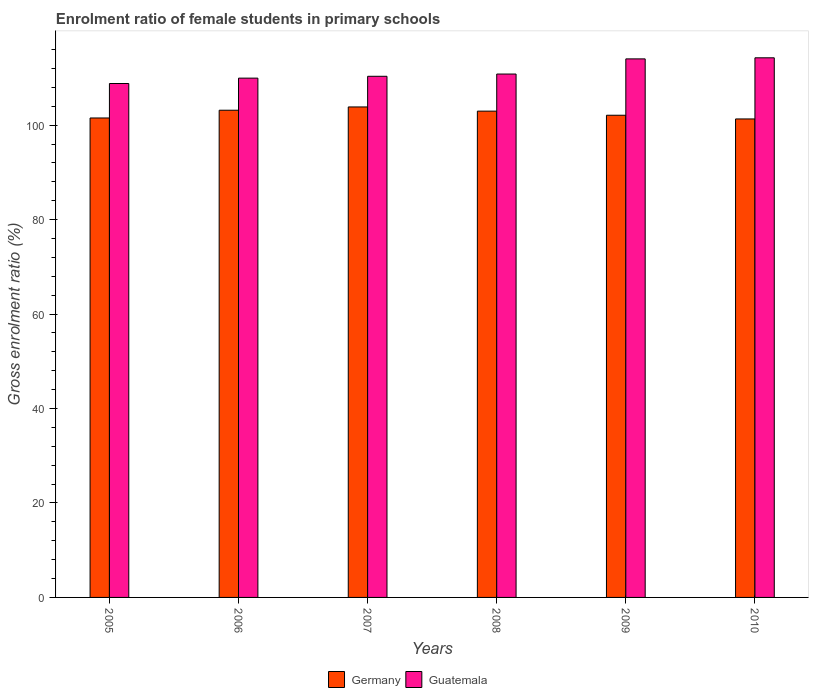What is the label of the 4th group of bars from the left?
Provide a short and direct response. 2008. In how many cases, is the number of bars for a given year not equal to the number of legend labels?
Your answer should be compact. 0. What is the enrolment ratio of female students in primary schools in Guatemala in 2007?
Provide a short and direct response. 110.36. Across all years, what is the maximum enrolment ratio of female students in primary schools in Guatemala?
Offer a very short reply. 114.27. Across all years, what is the minimum enrolment ratio of female students in primary schools in Guatemala?
Your response must be concise. 108.83. In which year was the enrolment ratio of female students in primary schools in Germany maximum?
Offer a terse response. 2007. What is the total enrolment ratio of female students in primary schools in Germany in the graph?
Your answer should be compact. 614.99. What is the difference between the enrolment ratio of female students in primary schools in Germany in 2009 and that in 2010?
Your response must be concise. 0.78. What is the difference between the enrolment ratio of female students in primary schools in Germany in 2007 and the enrolment ratio of female students in primary schools in Guatemala in 2005?
Your response must be concise. -4.97. What is the average enrolment ratio of female students in primary schools in Germany per year?
Offer a terse response. 102.5. In the year 2006, what is the difference between the enrolment ratio of female students in primary schools in Guatemala and enrolment ratio of female students in primary schools in Germany?
Make the answer very short. 6.8. In how many years, is the enrolment ratio of female students in primary schools in Germany greater than 32 %?
Your response must be concise. 6. What is the ratio of the enrolment ratio of female students in primary schools in Guatemala in 2005 to that in 2006?
Your response must be concise. 0.99. Is the enrolment ratio of female students in primary schools in Guatemala in 2006 less than that in 2010?
Make the answer very short. Yes. What is the difference between the highest and the second highest enrolment ratio of female students in primary schools in Germany?
Provide a short and direct response. 0.69. What is the difference between the highest and the lowest enrolment ratio of female students in primary schools in Germany?
Offer a very short reply. 2.54. In how many years, is the enrolment ratio of female students in primary schools in Guatemala greater than the average enrolment ratio of female students in primary schools in Guatemala taken over all years?
Make the answer very short. 2. What does the 1st bar from the right in 2006 represents?
Provide a short and direct response. Guatemala. How many years are there in the graph?
Give a very brief answer. 6. What is the difference between two consecutive major ticks on the Y-axis?
Give a very brief answer. 20. Are the values on the major ticks of Y-axis written in scientific E-notation?
Provide a short and direct response. No. Does the graph contain grids?
Offer a terse response. No. Where does the legend appear in the graph?
Provide a short and direct response. Bottom center. How many legend labels are there?
Your response must be concise. 2. What is the title of the graph?
Offer a terse response. Enrolment ratio of female students in primary schools. Does "Curacao" appear as one of the legend labels in the graph?
Provide a succinct answer. No. What is the Gross enrolment ratio (%) in Germany in 2005?
Make the answer very short. 101.53. What is the Gross enrolment ratio (%) of Guatemala in 2005?
Make the answer very short. 108.83. What is the Gross enrolment ratio (%) of Germany in 2006?
Offer a very short reply. 103.17. What is the Gross enrolment ratio (%) of Guatemala in 2006?
Ensure brevity in your answer.  109.97. What is the Gross enrolment ratio (%) of Germany in 2007?
Keep it short and to the point. 103.87. What is the Gross enrolment ratio (%) in Guatemala in 2007?
Offer a terse response. 110.36. What is the Gross enrolment ratio (%) in Germany in 2008?
Your response must be concise. 102.98. What is the Gross enrolment ratio (%) of Guatemala in 2008?
Keep it short and to the point. 110.84. What is the Gross enrolment ratio (%) of Germany in 2009?
Provide a short and direct response. 102.11. What is the Gross enrolment ratio (%) of Guatemala in 2009?
Give a very brief answer. 114.05. What is the Gross enrolment ratio (%) of Germany in 2010?
Provide a succinct answer. 101.33. What is the Gross enrolment ratio (%) of Guatemala in 2010?
Ensure brevity in your answer.  114.27. Across all years, what is the maximum Gross enrolment ratio (%) in Germany?
Make the answer very short. 103.87. Across all years, what is the maximum Gross enrolment ratio (%) in Guatemala?
Offer a very short reply. 114.27. Across all years, what is the minimum Gross enrolment ratio (%) of Germany?
Make the answer very short. 101.33. Across all years, what is the minimum Gross enrolment ratio (%) in Guatemala?
Offer a terse response. 108.83. What is the total Gross enrolment ratio (%) in Germany in the graph?
Keep it short and to the point. 614.99. What is the total Gross enrolment ratio (%) in Guatemala in the graph?
Your answer should be compact. 668.32. What is the difference between the Gross enrolment ratio (%) of Germany in 2005 and that in 2006?
Your answer should be compact. -1.64. What is the difference between the Gross enrolment ratio (%) of Guatemala in 2005 and that in 2006?
Your response must be concise. -1.14. What is the difference between the Gross enrolment ratio (%) in Germany in 2005 and that in 2007?
Your answer should be very brief. -2.34. What is the difference between the Gross enrolment ratio (%) in Guatemala in 2005 and that in 2007?
Your response must be concise. -1.53. What is the difference between the Gross enrolment ratio (%) in Germany in 2005 and that in 2008?
Keep it short and to the point. -1.45. What is the difference between the Gross enrolment ratio (%) in Guatemala in 2005 and that in 2008?
Your answer should be very brief. -2. What is the difference between the Gross enrolment ratio (%) in Germany in 2005 and that in 2009?
Give a very brief answer. -0.58. What is the difference between the Gross enrolment ratio (%) in Guatemala in 2005 and that in 2009?
Your answer should be compact. -5.21. What is the difference between the Gross enrolment ratio (%) in Germany in 2005 and that in 2010?
Your answer should be compact. 0.2. What is the difference between the Gross enrolment ratio (%) in Guatemala in 2005 and that in 2010?
Your answer should be compact. -5.44. What is the difference between the Gross enrolment ratio (%) in Germany in 2006 and that in 2007?
Ensure brevity in your answer.  -0.69. What is the difference between the Gross enrolment ratio (%) in Guatemala in 2006 and that in 2007?
Your answer should be very brief. -0.39. What is the difference between the Gross enrolment ratio (%) in Germany in 2006 and that in 2008?
Give a very brief answer. 0.19. What is the difference between the Gross enrolment ratio (%) of Guatemala in 2006 and that in 2008?
Keep it short and to the point. -0.87. What is the difference between the Gross enrolment ratio (%) in Germany in 2006 and that in 2009?
Provide a succinct answer. 1.06. What is the difference between the Gross enrolment ratio (%) in Guatemala in 2006 and that in 2009?
Your response must be concise. -4.08. What is the difference between the Gross enrolment ratio (%) of Germany in 2006 and that in 2010?
Your response must be concise. 1.85. What is the difference between the Gross enrolment ratio (%) of Guatemala in 2006 and that in 2010?
Keep it short and to the point. -4.31. What is the difference between the Gross enrolment ratio (%) in Germany in 2007 and that in 2008?
Provide a short and direct response. 0.89. What is the difference between the Gross enrolment ratio (%) in Guatemala in 2007 and that in 2008?
Provide a succinct answer. -0.48. What is the difference between the Gross enrolment ratio (%) in Germany in 2007 and that in 2009?
Provide a succinct answer. 1.76. What is the difference between the Gross enrolment ratio (%) in Guatemala in 2007 and that in 2009?
Ensure brevity in your answer.  -3.69. What is the difference between the Gross enrolment ratio (%) of Germany in 2007 and that in 2010?
Your answer should be compact. 2.54. What is the difference between the Gross enrolment ratio (%) in Guatemala in 2007 and that in 2010?
Keep it short and to the point. -3.91. What is the difference between the Gross enrolment ratio (%) in Germany in 2008 and that in 2009?
Offer a terse response. 0.87. What is the difference between the Gross enrolment ratio (%) in Guatemala in 2008 and that in 2009?
Offer a very short reply. -3.21. What is the difference between the Gross enrolment ratio (%) of Germany in 2008 and that in 2010?
Offer a very short reply. 1.65. What is the difference between the Gross enrolment ratio (%) of Guatemala in 2008 and that in 2010?
Keep it short and to the point. -3.44. What is the difference between the Gross enrolment ratio (%) in Germany in 2009 and that in 2010?
Provide a short and direct response. 0.78. What is the difference between the Gross enrolment ratio (%) in Guatemala in 2009 and that in 2010?
Provide a succinct answer. -0.23. What is the difference between the Gross enrolment ratio (%) in Germany in 2005 and the Gross enrolment ratio (%) in Guatemala in 2006?
Keep it short and to the point. -8.44. What is the difference between the Gross enrolment ratio (%) in Germany in 2005 and the Gross enrolment ratio (%) in Guatemala in 2007?
Give a very brief answer. -8.83. What is the difference between the Gross enrolment ratio (%) in Germany in 2005 and the Gross enrolment ratio (%) in Guatemala in 2008?
Provide a succinct answer. -9.3. What is the difference between the Gross enrolment ratio (%) in Germany in 2005 and the Gross enrolment ratio (%) in Guatemala in 2009?
Ensure brevity in your answer.  -12.51. What is the difference between the Gross enrolment ratio (%) in Germany in 2005 and the Gross enrolment ratio (%) in Guatemala in 2010?
Make the answer very short. -12.74. What is the difference between the Gross enrolment ratio (%) of Germany in 2006 and the Gross enrolment ratio (%) of Guatemala in 2007?
Offer a terse response. -7.19. What is the difference between the Gross enrolment ratio (%) of Germany in 2006 and the Gross enrolment ratio (%) of Guatemala in 2008?
Your answer should be compact. -7.66. What is the difference between the Gross enrolment ratio (%) in Germany in 2006 and the Gross enrolment ratio (%) in Guatemala in 2009?
Ensure brevity in your answer.  -10.87. What is the difference between the Gross enrolment ratio (%) in Germany in 2006 and the Gross enrolment ratio (%) in Guatemala in 2010?
Give a very brief answer. -11.1. What is the difference between the Gross enrolment ratio (%) in Germany in 2007 and the Gross enrolment ratio (%) in Guatemala in 2008?
Ensure brevity in your answer.  -6.97. What is the difference between the Gross enrolment ratio (%) in Germany in 2007 and the Gross enrolment ratio (%) in Guatemala in 2009?
Offer a terse response. -10.18. What is the difference between the Gross enrolment ratio (%) in Germany in 2007 and the Gross enrolment ratio (%) in Guatemala in 2010?
Your answer should be compact. -10.41. What is the difference between the Gross enrolment ratio (%) of Germany in 2008 and the Gross enrolment ratio (%) of Guatemala in 2009?
Your response must be concise. -11.07. What is the difference between the Gross enrolment ratio (%) of Germany in 2008 and the Gross enrolment ratio (%) of Guatemala in 2010?
Offer a terse response. -11.29. What is the difference between the Gross enrolment ratio (%) of Germany in 2009 and the Gross enrolment ratio (%) of Guatemala in 2010?
Provide a short and direct response. -12.16. What is the average Gross enrolment ratio (%) in Germany per year?
Your response must be concise. 102.5. What is the average Gross enrolment ratio (%) in Guatemala per year?
Your answer should be compact. 111.39. In the year 2005, what is the difference between the Gross enrolment ratio (%) in Germany and Gross enrolment ratio (%) in Guatemala?
Keep it short and to the point. -7.3. In the year 2006, what is the difference between the Gross enrolment ratio (%) in Germany and Gross enrolment ratio (%) in Guatemala?
Ensure brevity in your answer.  -6.8. In the year 2007, what is the difference between the Gross enrolment ratio (%) of Germany and Gross enrolment ratio (%) of Guatemala?
Offer a very short reply. -6.49. In the year 2008, what is the difference between the Gross enrolment ratio (%) of Germany and Gross enrolment ratio (%) of Guatemala?
Make the answer very short. -7.86. In the year 2009, what is the difference between the Gross enrolment ratio (%) of Germany and Gross enrolment ratio (%) of Guatemala?
Provide a short and direct response. -11.94. In the year 2010, what is the difference between the Gross enrolment ratio (%) in Germany and Gross enrolment ratio (%) in Guatemala?
Keep it short and to the point. -12.95. What is the ratio of the Gross enrolment ratio (%) of Germany in 2005 to that in 2006?
Your answer should be very brief. 0.98. What is the ratio of the Gross enrolment ratio (%) in Guatemala in 2005 to that in 2006?
Keep it short and to the point. 0.99. What is the ratio of the Gross enrolment ratio (%) in Germany in 2005 to that in 2007?
Provide a succinct answer. 0.98. What is the ratio of the Gross enrolment ratio (%) of Guatemala in 2005 to that in 2007?
Provide a short and direct response. 0.99. What is the ratio of the Gross enrolment ratio (%) in Germany in 2005 to that in 2008?
Your answer should be compact. 0.99. What is the ratio of the Gross enrolment ratio (%) in Guatemala in 2005 to that in 2008?
Keep it short and to the point. 0.98. What is the ratio of the Gross enrolment ratio (%) of Germany in 2005 to that in 2009?
Your answer should be very brief. 0.99. What is the ratio of the Gross enrolment ratio (%) of Guatemala in 2005 to that in 2009?
Offer a terse response. 0.95. What is the ratio of the Gross enrolment ratio (%) in Germany in 2005 to that in 2010?
Give a very brief answer. 1. What is the ratio of the Gross enrolment ratio (%) in Germany in 2006 to that in 2007?
Provide a succinct answer. 0.99. What is the ratio of the Gross enrolment ratio (%) of Guatemala in 2006 to that in 2008?
Make the answer very short. 0.99. What is the ratio of the Gross enrolment ratio (%) of Germany in 2006 to that in 2009?
Provide a short and direct response. 1.01. What is the ratio of the Gross enrolment ratio (%) in Guatemala in 2006 to that in 2009?
Give a very brief answer. 0.96. What is the ratio of the Gross enrolment ratio (%) in Germany in 2006 to that in 2010?
Your response must be concise. 1.02. What is the ratio of the Gross enrolment ratio (%) in Guatemala in 2006 to that in 2010?
Keep it short and to the point. 0.96. What is the ratio of the Gross enrolment ratio (%) of Germany in 2007 to that in 2008?
Give a very brief answer. 1.01. What is the ratio of the Gross enrolment ratio (%) of Guatemala in 2007 to that in 2008?
Keep it short and to the point. 1. What is the ratio of the Gross enrolment ratio (%) in Germany in 2007 to that in 2009?
Offer a very short reply. 1.02. What is the ratio of the Gross enrolment ratio (%) in Guatemala in 2007 to that in 2009?
Offer a terse response. 0.97. What is the ratio of the Gross enrolment ratio (%) of Germany in 2007 to that in 2010?
Keep it short and to the point. 1.03. What is the ratio of the Gross enrolment ratio (%) in Guatemala in 2007 to that in 2010?
Offer a very short reply. 0.97. What is the ratio of the Gross enrolment ratio (%) in Germany in 2008 to that in 2009?
Make the answer very short. 1.01. What is the ratio of the Gross enrolment ratio (%) in Guatemala in 2008 to that in 2009?
Give a very brief answer. 0.97. What is the ratio of the Gross enrolment ratio (%) of Germany in 2008 to that in 2010?
Your response must be concise. 1.02. What is the ratio of the Gross enrolment ratio (%) of Guatemala in 2008 to that in 2010?
Make the answer very short. 0.97. What is the ratio of the Gross enrolment ratio (%) in Germany in 2009 to that in 2010?
Keep it short and to the point. 1.01. What is the ratio of the Gross enrolment ratio (%) of Guatemala in 2009 to that in 2010?
Ensure brevity in your answer.  1. What is the difference between the highest and the second highest Gross enrolment ratio (%) of Germany?
Provide a short and direct response. 0.69. What is the difference between the highest and the second highest Gross enrolment ratio (%) in Guatemala?
Keep it short and to the point. 0.23. What is the difference between the highest and the lowest Gross enrolment ratio (%) in Germany?
Your response must be concise. 2.54. What is the difference between the highest and the lowest Gross enrolment ratio (%) of Guatemala?
Give a very brief answer. 5.44. 